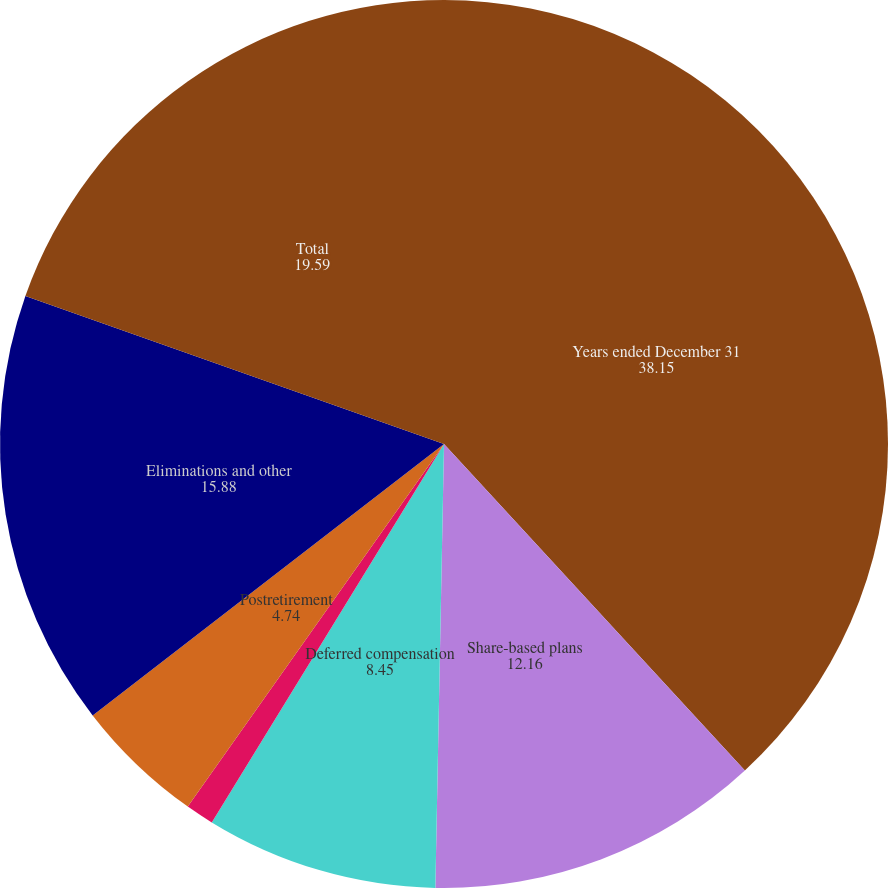<chart> <loc_0><loc_0><loc_500><loc_500><pie_chart><fcel>Years ended December 31<fcel>Share-based plans<fcel>Deferred compensation<fcel>Pension<fcel>Postretirement<fcel>Eliminations and other<fcel>Total<nl><fcel>38.15%<fcel>12.16%<fcel>8.45%<fcel>1.03%<fcel>4.74%<fcel>15.88%<fcel>19.59%<nl></chart> 